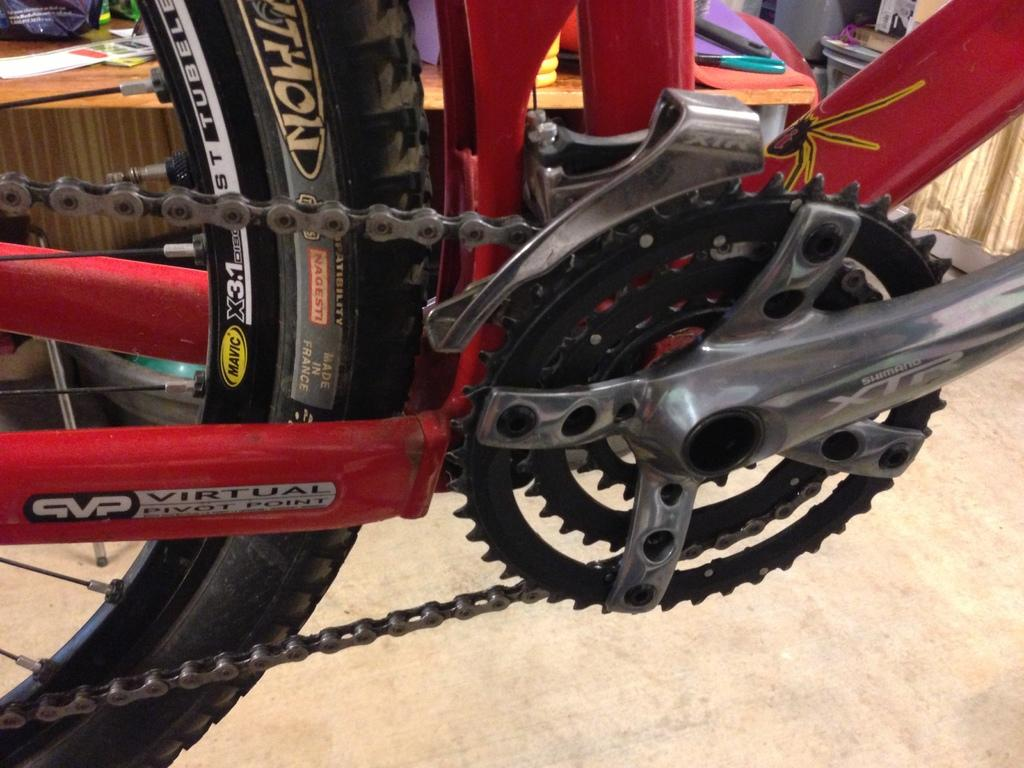What is the main object in the image? There is a bicycle in the image. What can be seen in the background of the image? There is a table in the background of the image. What is placed on the table in the background? There are things placed on the table in the background of the image. Can you tell me what color the queen's dress is in the image? There is no queen present in the image, so we cannot determine the color of her dress. 